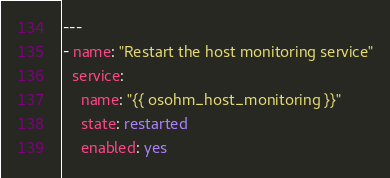<code> <loc_0><loc_0><loc_500><loc_500><_YAML_>---
- name: "Restart the host monitoring service"
  service:
    name: "{{ osohm_host_monitoring }}"
    state: restarted
    enabled: yes
</code> 